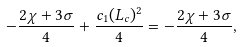Convert formula to latex. <formula><loc_0><loc_0><loc_500><loc_500>- \frac { 2 \chi + 3 \sigma } { 4 } + \frac { c _ { 1 } ( L _ { c } ) ^ { 2 } } { 4 } = - \frac { 2 \chi + 3 \sigma } { 4 } ,</formula> 